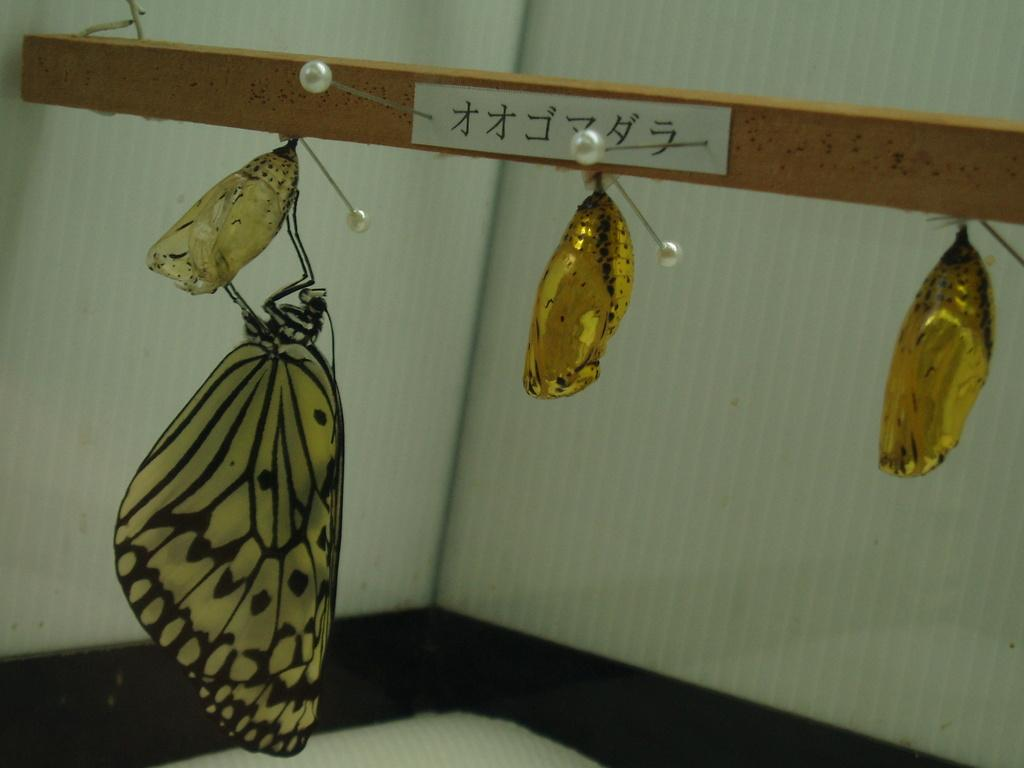What is the main object in the image? There is a wooden plank in the image. What insects can be seen in the image? There are two moths and a butterfly in the image. What is the background of the image like? There is a white wall with lines in the background of the image. What brand of toothpaste is visible on the wooden plank in the image? There is no toothpaste present in the image. What type of stove is being used by the moths in the image? There are no moths using a stove in the image; they are simply resting on the wooden plank and the butterfly. 